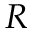Convert formula to latex. <formula><loc_0><loc_0><loc_500><loc_500>R</formula> 